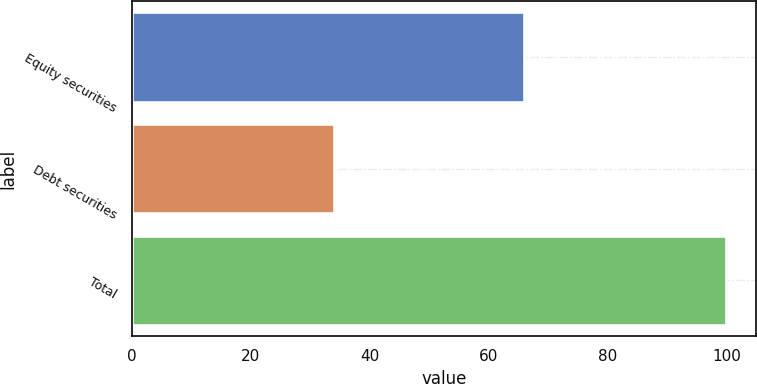<chart> <loc_0><loc_0><loc_500><loc_500><bar_chart><fcel>Equity securities<fcel>Debt securities<fcel>Total<nl><fcel>66<fcel>34<fcel>100<nl></chart> 